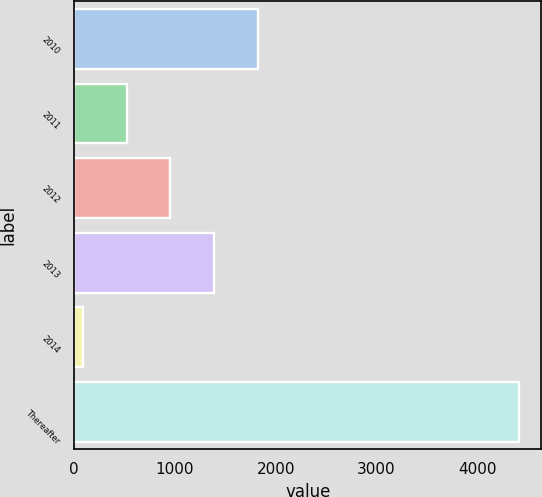Convert chart. <chart><loc_0><loc_0><loc_500><loc_500><bar_chart><fcel>2010<fcel>2011<fcel>2012<fcel>2013<fcel>2014<fcel>Thereafter<nl><fcel>1821.54<fcel>524.01<fcel>956.52<fcel>1389.03<fcel>91.5<fcel>4416.6<nl></chart> 